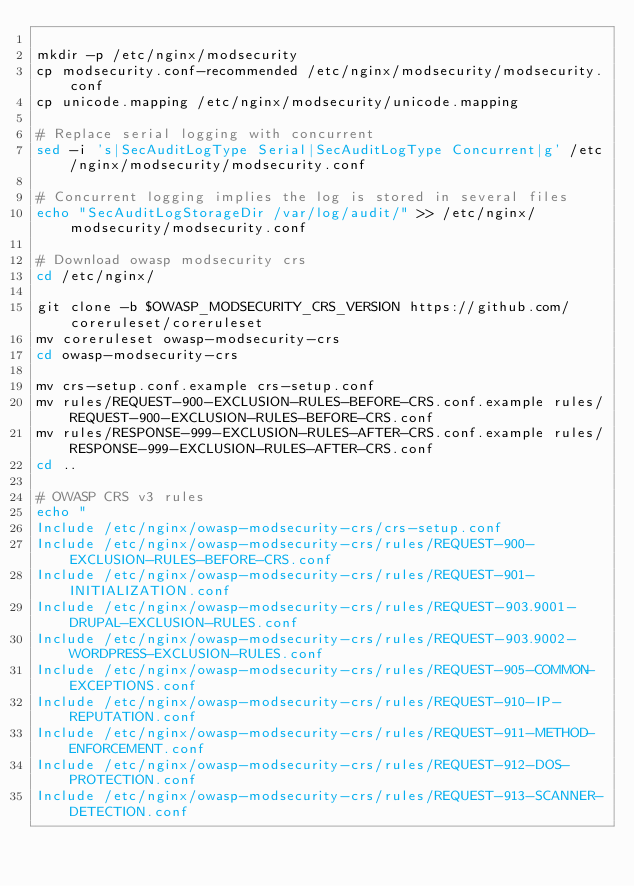<code> <loc_0><loc_0><loc_500><loc_500><_Bash_>
mkdir -p /etc/nginx/modsecurity
cp modsecurity.conf-recommended /etc/nginx/modsecurity/modsecurity.conf
cp unicode.mapping /etc/nginx/modsecurity/unicode.mapping

# Replace serial logging with concurrent
sed -i 's|SecAuditLogType Serial|SecAuditLogType Concurrent|g' /etc/nginx/modsecurity/modsecurity.conf

# Concurrent logging implies the log is stored in several files
echo "SecAuditLogStorageDir /var/log/audit/" >> /etc/nginx/modsecurity/modsecurity.conf

# Download owasp modsecurity crs
cd /etc/nginx/

git clone -b $OWASP_MODSECURITY_CRS_VERSION https://github.com/coreruleset/coreruleset
mv coreruleset owasp-modsecurity-crs
cd owasp-modsecurity-crs

mv crs-setup.conf.example crs-setup.conf
mv rules/REQUEST-900-EXCLUSION-RULES-BEFORE-CRS.conf.example rules/REQUEST-900-EXCLUSION-RULES-BEFORE-CRS.conf
mv rules/RESPONSE-999-EXCLUSION-RULES-AFTER-CRS.conf.example rules/RESPONSE-999-EXCLUSION-RULES-AFTER-CRS.conf
cd ..

# OWASP CRS v3 rules
echo "
Include /etc/nginx/owasp-modsecurity-crs/crs-setup.conf
Include /etc/nginx/owasp-modsecurity-crs/rules/REQUEST-900-EXCLUSION-RULES-BEFORE-CRS.conf
Include /etc/nginx/owasp-modsecurity-crs/rules/REQUEST-901-INITIALIZATION.conf
Include /etc/nginx/owasp-modsecurity-crs/rules/REQUEST-903.9001-DRUPAL-EXCLUSION-RULES.conf
Include /etc/nginx/owasp-modsecurity-crs/rules/REQUEST-903.9002-WORDPRESS-EXCLUSION-RULES.conf
Include /etc/nginx/owasp-modsecurity-crs/rules/REQUEST-905-COMMON-EXCEPTIONS.conf
Include /etc/nginx/owasp-modsecurity-crs/rules/REQUEST-910-IP-REPUTATION.conf
Include /etc/nginx/owasp-modsecurity-crs/rules/REQUEST-911-METHOD-ENFORCEMENT.conf
Include /etc/nginx/owasp-modsecurity-crs/rules/REQUEST-912-DOS-PROTECTION.conf
Include /etc/nginx/owasp-modsecurity-crs/rules/REQUEST-913-SCANNER-DETECTION.conf</code> 